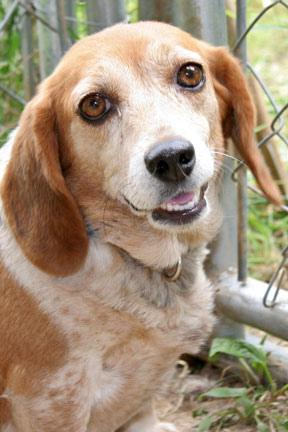Question: what is the fence made of?
Choices:
A. Wood.
B. Plastic.
C. Pallets.
D. Metal.
Answer with the letter. Answer: D Question: what color is the dog?
Choices:
A. Black.
B. Red.
C. Brown and white.
D. Yellow.
Answer with the letter. Answer: C Question: where was the picture taken?
Choices:
A. Hiking trail.
B. IN the woods.
C. Nature park.
D. National forest.
Answer with the letter. Answer: B 